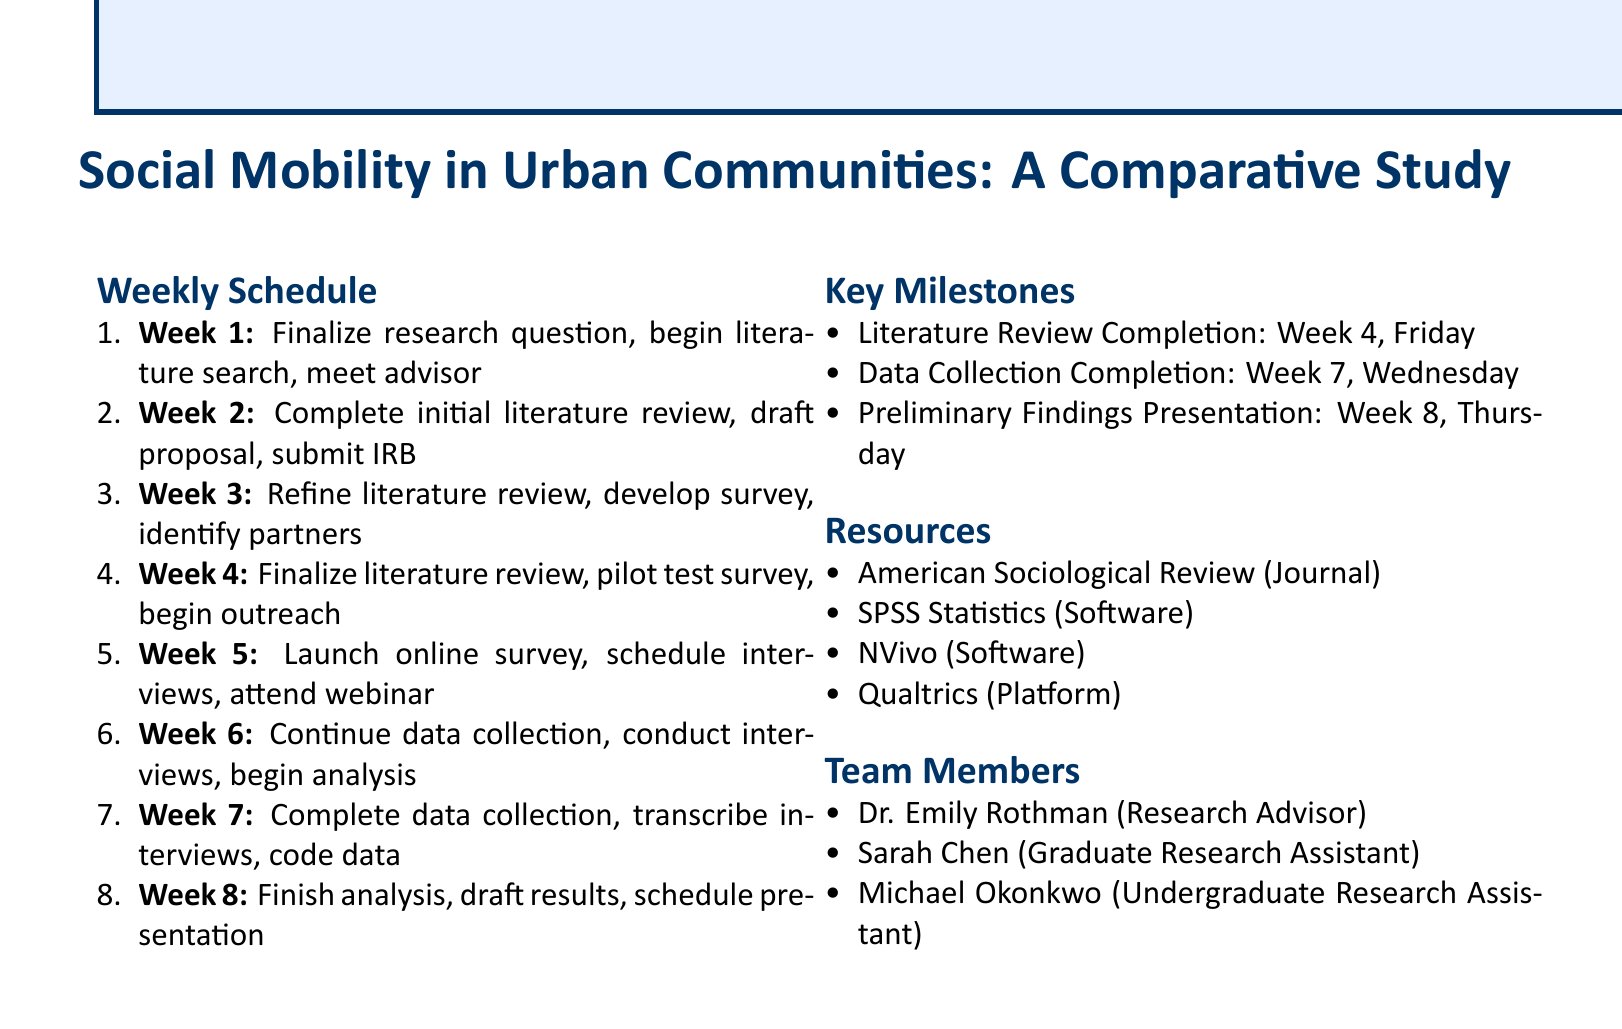What is the title of the research project? The title of the research project is listed at the beginning of the document.
Answer: Social Mobility in Urban Communities: A Comparative Study What is the deadline for the literature review completion? The milestone for literature review completion is specifically noted in the key milestones section.
Answer: Week 4, Friday How many sources are required for the initial literature review? The number of sources for the literature review is indicated in the tasks for Week 2.
Answer: minimum 20 sources Who is the research advisor? The research advisor's name is mentioned in the team members section.
Answer: Dr. Emily Rothman During which week is the data collection expected to be completed? The document specifies a milestone regarding data collection completion.
Answer: Week 7, Wednesday What software is mentioned for qualitative data analysis? The resources section lists software specifically for qualitative data analysis.
Answer: NVivo In what week is the launch of the online survey scheduled? The timeline for launching the online survey is included in the tasks for Week 5.
Answer: Week 5 Which journal is identified as a key resource for recent studies on social mobility? The resources section explicitly names a journal that is relevant to the study.
Answer: American Sociological Review What task is scheduled for week 6 related to data collection? The tasks for week 6 include specific details about ongoing data collection efforts.
Answer: Continue data collection (target: 50% of survey responses) 